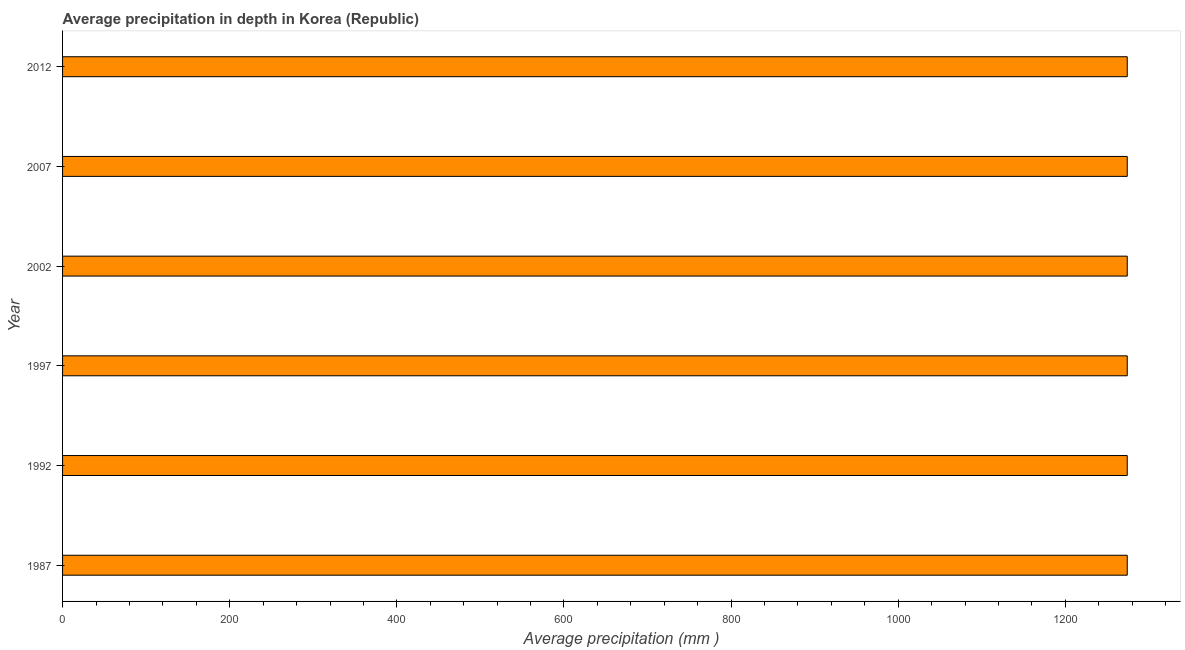What is the title of the graph?
Your answer should be compact. Average precipitation in depth in Korea (Republic). What is the label or title of the X-axis?
Your answer should be very brief. Average precipitation (mm ). What is the average precipitation in depth in 2002?
Offer a terse response. 1274. Across all years, what is the maximum average precipitation in depth?
Offer a terse response. 1274. Across all years, what is the minimum average precipitation in depth?
Your answer should be compact. 1274. In which year was the average precipitation in depth maximum?
Provide a short and direct response. 1987. In which year was the average precipitation in depth minimum?
Keep it short and to the point. 1987. What is the sum of the average precipitation in depth?
Your response must be concise. 7644. What is the average average precipitation in depth per year?
Your response must be concise. 1274. What is the median average precipitation in depth?
Ensure brevity in your answer.  1274. Do a majority of the years between 1987 and 2007 (inclusive) have average precipitation in depth greater than 520 mm?
Keep it short and to the point. Yes. What is the ratio of the average precipitation in depth in 1992 to that in 2002?
Provide a succinct answer. 1. Is the average precipitation in depth in 1987 less than that in 2012?
Ensure brevity in your answer.  No. Is the difference between the average precipitation in depth in 2002 and 2007 greater than the difference between any two years?
Provide a succinct answer. Yes. Is the sum of the average precipitation in depth in 1987 and 1997 greater than the maximum average precipitation in depth across all years?
Offer a very short reply. Yes. What is the difference between the highest and the lowest average precipitation in depth?
Provide a succinct answer. 0. In how many years, is the average precipitation in depth greater than the average average precipitation in depth taken over all years?
Give a very brief answer. 0. How many bars are there?
Offer a very short reply. 6. Are all the bars in the graph horizontal?
Your answer should be compact. Yes. How many years are there in the graph?
Give a very brief answer. 6. Are the values on the major ticks of X-axis written in scientific E-notation?
Your response must be concise. No. What is the Average precipitation (mm ) in 1987?
Make the answer very short. 1274. What is the Average precipitation (mm ) in 1992?
Your answer should be very brief. 1274. What is the Average precipitation (mm ) in 1997?
Your answer should be compact. 1274. What is the Average precipitation (mm ) of 2002?
Provide a short and direct response. 1274. What is the Average precipitation (mm ) of 2007?
Provide a short and direct response. 1274. What is the Average precipitation (mm ) in 2012?
Offer a very short reply. 1274. What is the difference between the Average precipitation (mm ) in 1987 and 1992?
Offer a very short reply. 0. What is the difference between the Average precipitation (mm ) in 1987 and 1997?
Ensure brevity in your answer.  0. What is the difference between the Average precipitation (mm ) in 1987 and 2002?
Provide a short and direct response. 0. What is the difference between the Average precipitation (mm ) in 1992 and 1997?
Offer a terse response. 0. What is the difference between the Average precipitation (mm ) in 1992 and 2002?
Keep it short and to the point. 0. What is the difference between the Average precipitation (mm ) in 1992 and 2012?
Your answer should be compact. 0. What is the difference between the Average precipitation (mm ) in 1997 and 2002?
Provide a short and direct response. 0. What is the difference between the Average precipitation (mm ) in 1997 and 2007?
Make the answer very short. 0. What is the difference between the Average precipitation (mm ) in 1997 and 2012?
Provide a short and direct response. 0. What is the ratio of the Average precipitation (mm ) in 1987 to that in 1997?
Your answer should be very brief. 1. What is the ratio of the Average precipitation (mm ) in 1987 to that in 2012?
Your answer should be very brief. 1. What is the ratio of the Average precipitation (mm ) in 1992 to that in 1997?
Offer a terse response. 1. What is the ratio of the Average precipitation (mm ) in 1992 to that in 2007?
Your answer should be very brief. 1. What is the ratio of the Average precipitation (mm ) in 1992 to that in 2012?
Your response must be concise. 1. What is the ratio of the Average precipitation (mm ) in 1997 to that in 2012?
Make the answer very short. 1. What is the ratio of the Average precipitation (mm ) in 2002 to that in 2007?
Give a very brief answer. 1. What is the ratio of the Average precipitation (mm ) in 2002 to that in 2012?
Provide a succinct answer. 1. What is the ratio of the Average precipitation (mm ) in 2007 to that in 2012?
Your answer should be compact. 1. 